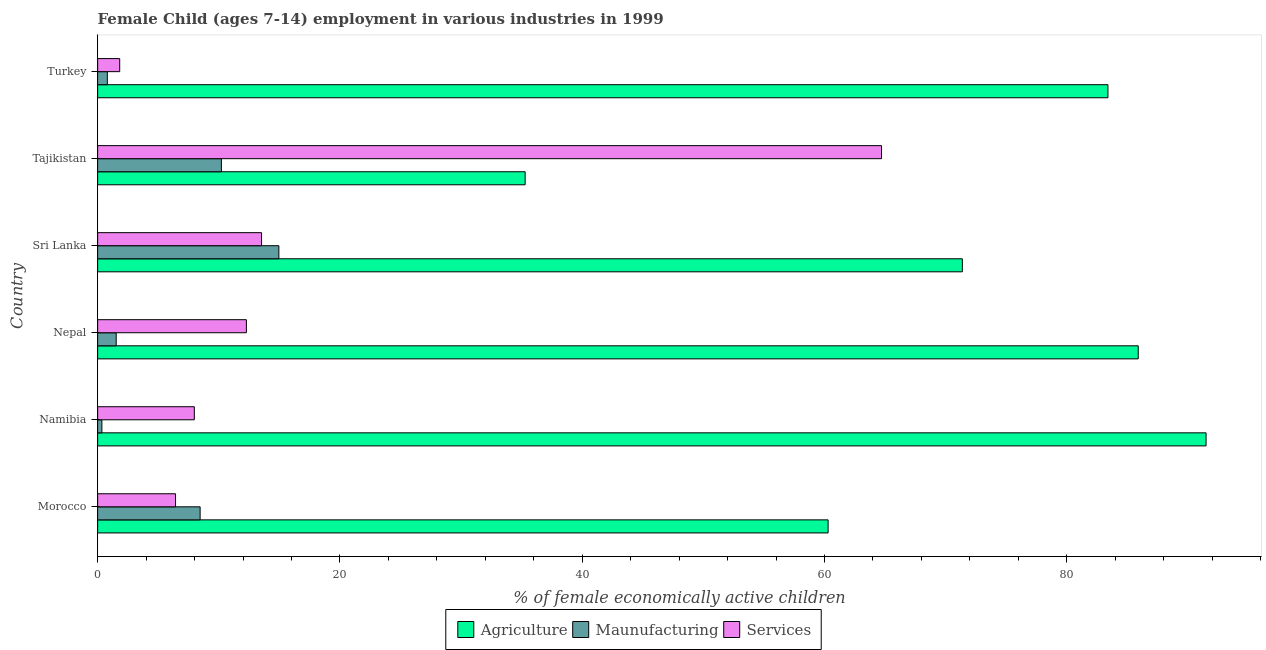How many groups of bars are there?
Your answer should be very brief. 6. What is the label of the 3rd group of bars from the top?
Your answer should be compact. Sri Lanka. In how many cases, is the number of bars for a given country not equal to the number of legend labels?
Provide a succinct answer. 0. What is the percentage of economically active children in agriculture in Nepal?
Offer a terse response. 85.9. Across all countries, what is the maximum percentage of economically active children in agriculture?
Offer a terse response. 91.5. In which country was the percentage of economically active children in agriculture maximum?
Ensure brevity in your answer.  Namibia. In which country was the percentage of economically active children in services minimum?
Keep it short and to the point. Turkey. What is the total percentage of economically active children in agriculture in the graph?
Your answer should be very brief. 427.77. What is the difference between the percentage of economically active children in agriculture in Sri Lanka and that in Turkey?
Provide a short and direct response. -12.02. What is the difference between the percentage of economically active children in agriculture in Morocco and the percentage of economically active children in services in Tajikistan?
Your answer should be very brief. -4.41. What is the average percentage of economically active children in services per country?
Your response must be concise. 17.79. What is the difference between the percentage of economically active children in services and percentage of economically active children in agriculture in Turkey?
Provide a short and direct response. -81.58. In how many countries, is the percentage of economically active children in agriculture greater than 12 %?
Make the answer very short. 6. What is the ratio of the percentage of economically active children in agriculture in Namibia to that in Turkey?
Keep it short and to the point. 1.1. Is the percentage of economically active children in services in Sri Lanka less than that in Turkey?
Provide a succinct answer. No. Is the difference between the percentage of economically active children in manufacturing in Morocco and Sri Lanka greater than the difference between the percentage of economically active children in services in Morocco and Sri Lanka?
Give a very brief answer. Yes. What is the difference between the highest and the second highest percentage of economically active children in manufacturing?
Your answer should be compact. 4.74. What is the difference between the highest and the lowest percentage of economically active children in agriculture?
Provide a short and direct response. 56.21. In how many countries, is the percentage of economically active children in agriculture greater than the average percentage of economically active children in agriculture taken over all countries?
Your response must be concise. 4. What does the 1st bar from the top in Nepal represents?
Ensure brevity in your answer.  Services. What does the 2nd bar from the bottom in Sri Lanka represents?
Keep it short and to the point. Maunufacturing. Are all the bars in the graph horizontal?
Your answer should be compact. Yes. How many countries are there in the graph?
Your answer should be compact. 6. Does the graph contain any zero values?
Ensure brevity in your answer.  No. How many legend labels are there?
Offer a terse response. 3. What is the title of the graph?
Provide a succinct answer. Female Child (ages 7-14) employment in various industries in 1999. Does "New Zealand" appear as one of the legend labels in the graph?
Offer a terse response. No. What is the label or title of the X-axis?
Give a very brief answer. % of female economically active children. What is the % of female economically active children of Agriculture in Morocco?
Ensure brevity in your answer.  60.3. What is the % of female economically active children in Maunufacturing in Morocco?
Your response must be concise. 8.46. What is the % of female economically active children in Services in Morocco?
Your response must be concise. 6.43. What is the % of female economically active children of Agriculture in Namibia?
Offer a terse response. 91.5. What is the % of female economically active children of Maunufacturing in Namibia?
Provide a short and direct response. 0.35. What is the % of female economically active children of Services in Namibia?
Ensure brevity in your answer.  7.98. What is the % of female economically active children of Agriculture in Nepal?
Your answer should be very brief. 85.9. What is the % of female economically active children in Maunufacturing in Nepal?
Ensure brevity in your answer.  1.53. What is the % of female economically active children in Services in Nepal?
Ensure brevity in your answer.  12.28. What is the % of female economically active children in Agriculture in Sri Lanka?
Provide a succinct answer. 71.38. What is the % of female economically active children of Maunufacturing in Sri Lanka?
Provide a short and direct response. 14.96. What is the % of female economically active children in Services in Sri Lanka?
Your answer should be very brief. 13.53. What is the % of female economically active children in Agriculture in Tajikistan?
Your response must be concise. 35.29. What is the % of female economically active children of Maunufacturing in Tajikistan?
Offer a very short reply. 10.22. What is the % of female economically active children of Services in Tajikistan?
Offer a terse response. 64.71. What is the % of female economically active children in Agriculture in Turkey?
Offer a very short reply. 83.4. What is the % of female economically active children of Services in Turkey?
Your answer should be very brief. 1.82. Across all countries, what is the maximum % of female economically active children of Agriculture?
Provide a short and direct response. 91.5. Across all countries, what is the maximum % of female economically active children of Maunufacturing?
Make the answer very short. 14.96. Across all countries, what is the maximum % of female economically active children of Services?
Your answer should be very brief. 64.71. Across all countries, what is the minimum % of female economically active children in Agriculture?
Offer a very short reply. 35.29. Across all countries, what is the minimum % of female economically active children of Services?
Your answer should be compact. 1.82. What is the total % of female economically active children of Agriculture in the graph?
Ensure brevity in your answer.  427.77. What is the total % of female economically active children in Maunufacturing in the graph?
Provide a short and direct response. 36.32. What is the total % of female economically active children in Services in the graph?
Make the answer very short. 106.75. What is the difference between the % of female economically active children of Agriculture in Morocco and that in Namibia?
Provide a succinct answer. -31.2. What is the difference between the % of female economically active children in Maunufacturing in Morocco and that in Namibia?
Provide a succinct answer. 8.11. What is the difference between the % of female economically active children of Services in Morocco and that in Namibia?
Give a very brief answer. -1.55. What is the difference between the % of female economically active children in Agriculture in Morocco and that in Nepal?
Your answer should be compact. -25.6. What is the difference between the % of female economically active children of Maunufacturing in Morocco and that in Nepal?
Your answer should be very brief. 6.93. What is the difference between the % of female economically active children in Services in Morocco and that in Nepal?
Provide a succinct answer. -5.85. What is the difference between the % of female economically active children in Agriculture in Morocco and that in Sri Lanka?
Provide a succinct answer. -11.08. What is the difference between the % of female economically active children of Services in Morocco and that in Sri Lanka?
Offer a very short reply. -7.1. What is the difference between the % of female economically active children in Agriculture in Morocco and that in Tajikistan?
Provide a short and direct response. 25.01. What is the difference between the % of female economically active children in Maunufacturing in Morocco and that in Tajikistan?
Keep it short and to the point. -1.76. What is the difference between the % of female economically active children of Services in Morocco and that in Tajikistan?
Keep it short and to the point. -58.28. What is the difference between the % of female economically active children in Agriculture in Morocco and that in Turkey?
Your answer should be compact. -23.1. What is the difference between the % of female economically active children of Maunufacturing in Morocco and that in Turkey?
Ensure brevity in your answer.  7.66. What is the difference between the % of female economically active children of Services in Morocco and that in Turkey?
Keep it short and to the point. 4.61. What is the difference between the % of female economically active children of Agriculture in Namibia and that in Nepal?
Provide a short and direct response. 5.6. What is the difference between the % of female economically active children of Maunufacturing in Namibia and that in Nepal?
Provide a succinct answer. -1.18. What is the difference between the % of female economically active children in Agriculture in Namibia and that in Sri Lanka?
Give a very brief answer. 20.12. What is the difference between the % of female economically active children in Maunufacturing in Namibia and that in Sri Lanka?
Offer a very short reply. -14.61. What is the difference between the % of female economically active children of Services in Namibia and that in Sri Lanka?
Ensure brevity in your answer.  -5.55. What is the difference between the % of female economically active children in Agriculture in Namibia and that in Tajikistan?
Your response must be concise. 56.21. What is the difference between the % of female economically active children of Maunufacturing in Namibia and that in Tajikistan?
Make the answer very short. -9.87. What is the difference between the % of female economically active children of Services in Namibia and that in Tajikistan?
Ensure brevity in your answer.  -56.73. What is the difference between the % of female economically active children in Agriculture in Namibia and that in Turkey?
Give a very brief answer. 8.1. What is the difference between the % of female economically active children of Maunufacturing in Namibia and that in Turkey?
Make the answer very short. -0.45. What is the difference between the % of female economically active children in Services in Namibia and that in Turkey?
Your answer should be compact. 6.16. What is the difference between the % of female economically active children of Agriculture in Nepal and that in Sri Lanka?
Keep it short and to the point. 14.52. What is the difference between the % of female economically active children in Maunufacturing in Nepal and that in Sri Lanka?
Give a very brief answer. -13.43. What is the difference between the % of female economically active children of Services in Nepal and that in Sri Lanka?
Give a very brief answer. -1.25. What is the difference between the % of female economically active children in Agriculture in Nepal and that in Tajikistan?
Your answer should be very brief. 50.61. What is the difference between the % of female economically active children in Maunufacturing in Nepal and that in Tajikistan?
Your answer should be compact. -8.68. What is the difference between the % of female economically active children of Services in Nepal and that in Tajikistan?
Offer a terse response. -52.43. What is the difference between the % of female economically active children of Agriculture in Nepal and that in Turkey?
Make the answer very short. 2.5. What is the difference between the % of female economically active children in Maunufacturing in Nepal and that in Turkey?
Your answer should be very brief. 0.73. What is the difference between the % of female economically active children in Services in Nepal and that in Turkey?
Your answer should be compact. 10.46. What is the difference between the % of female economically active children of Agriculture in Sri Lanka and that in Tajikistan?
Your answer should be compact. 36.09. What is the difference between the % of female economically active children in Maunufacturing in Sri Lanka and that in Tajikistan?
Your answer should be compact. 4.74. What is the difference between the % of female economically active children of Services in Sri Lanka and that in Tajikistan?
Your answer should be very brief. -51.18. What is the difference between the % of female economically active children of Agriculture in Sri Lanka and that in Turkey?
Ensure brevity in your answer.  -12.02. What is the difference between the % of female economically active children of Maunufacturing in Sri Lanka and that in Turkey?
Your answer should be compact. 14.16. What is the difference between the % of female economically active children of Services in Sri Lanka and that in Turkey?
Ensure brevity in your answer.  11.71. What is the difference between the % of female economically active children in Agriculture in Tajikistan and that in Turkey?
Your answer should be very brief. -48.11. What is the difference between the % of female economically active children of Maunufacturing in Tajikistan and that in Turkey?
Your answer should be compact. 9.42. What is the difference between the % of female economically active children in Services in Tajikistan and that in Turkey?
Your answer should be very brief. 62.89. What is the difference between the % of female economically active children of Agriculture in Morocco and the % of female economically active children of Maunufacturing in Namibia?
Ensure brevity in your answer.  59.95. What is the difference between the % of female economically active children in Agriculture in Morocco and the % of female economically active children in Services in Namibia?
Offer a very short reply. 52.32. What is the difference between the % of female economically active children in Maunufacturing in Morocco and the % of female economically active children in Services in Namibia?
Provide a short and direct response. 0.48. What is the difference between the % of female economically active children in Agriculture in Morocco and the % of female economically active children in Maunufacturing in Nepal?
Your answer should be very brief. 58.77. What is the difference between the % of female economically active children of Agriculture in Morocco and the % of female economically active children of Services in Nepal?
Offer a terse response. 48.02. What is the difference between the % of female economically active children of Maunufacturing in Morocco and the % of female economically active children of Services in Nepal?
Your response must be concise. -3.82. What is the difference between the % of female economically active children in Agriculture in Morocco and the % of female economically active children in Maunufacturing in Sri Lanka?
Provide a succinct answer. 45.34. What is the difference between the % of female economically active children of Agriculture in Morocco and the % of female economically active children of Services in Sri Lanka?
Your response must be concise. 46.77. What is the difference between the % of female economically active children in Maunufacturing in Morocco and the % of female economically active children in Services in Sri Lanka?
Provide a short and direct response. -5.07. What is the difference between the % of female economically active children in Agriculture in Morocco and the % of female economically active children in Maunufacturing in Tajikistan?
Keep it short and to the point. 50.08. What is the difference between the % of female economically active children in Agriculture in Morocco and the % of female economically active children in Services in Tajikistan?
Your response must be concise. -4.41. What is the difference between the % of female economically active children of Maunufacturing in Morocco and the % of female economically active children of Services in Tajikistan?
Provide a succinct answer. -56.25. What is the difference between the % of female economically active children of Agriculture in Morocco and the % of female economically active children of Maunufacturing in Turkey?
Provide a succinct answer. 59.5. What is the difference between the % of female economically active children in Agriculture in Morocco and the % of female economically active children in Services in Turkey?
Your answer should be compact. 58.48. What is the difference between the % of female economically active children of Maunufacturing in Morocco and the % of female economically active children of Services in Turkey?
Provide a short and direct response. 6.64. What is the difference between the % of female economically active children of Agriculture in Namibia and the % of female economically active children of Maunufacturing in Nepal?
Make the answer very short. 89.97. What is the difference between the % of female economically active children of Agriculture in Namibia and the % of female economically active children of Services in Nepal?
Provide a succinct answer. 79.22. What is the difference between the % of female economically active children in Maunufacturing in Namibia and the % of female economically active children in Services in Nepal?
Your answer should be compact. -11.93. What is the difference between the % of female economically active children of Agriculture in Namibia and the % of female economically active children of Maunufacturing in Sri Lanka?
Provide a succinct answer. 76.54. What is the difference between the % of female economically active children in Agriculture in Namibia and the % of female economically active children in Services in Sri Lanka?
Your answer should be very brief. 77.97. What is the difference between the % of female economically active children of Maunufacturing in Namibia and the % of female economically active children of Services in Sri Lanka?
Your answer should be compact. -13.18. What is the difference between the % of female economically active children of Agriculture in Namibia and the % of female economically active children of Maunufacturing in Tajikistan?
Your response must be concise. 81.28. What is the difference between the % of female economically active children in Agriculture in Namibia and the % of female economically active children in Services in Tajikistan?
Make the answer very short. 26.79. What is the difference between the % of female economically active children in Maunufacturing in Namibia and the % of female economically active children in Services in Tajikistan?
Provide a succinct answer. -64.36. What is the difference between the % of female economically active children of Agriculture in Namibia and the % of female economically active children of Maunufacturing in Turkey?
Offer a very short reply. 90.7. What is the difference between the % of female economically active children of Agriculture in Namibia and the % of female economically active children of Services in Turkey?
Provide a succinct answer. 89.68. What is the difference between the % of female economically active children of Maunufacturing in Namibia and the % of female economically active children of Services in Turkey?
Offer a terse response. -1.47. What is the difference between the % of female economically active children in Agriculture in Nepal and the % of female economically active children in Maunufacturing in Sri Lanka?
Give a very brief answer. 70.94. What is the difference between the % of female economically active children of Agriculture in Nepal and the % of female economically active children of Services in Sri Lanka?
Your answer should be very brief. 72.37. What is the difference between the % of female economically active children of Maunufacturing in Nepal and the % of female economically active children of Services in Sri Lanka?
Make the answer very short. -12. What is the difference between the % of female economically active children in Agriculture in Nepal and the % of female economically active children in Maunufacturing in Tajikistan?
Keep it short and to the point. 75.68. What is the difference between the % of female economically active children in Agriculture in Nepal and the % of female economically active children in Services in Tajikistan?
Keep it short and to the point. 21.19. What is the difference between the % of female economically active children in Maunufacturing in Nepal and the % of female economically active children in Services in Tajikistan?
Keep it short and to the point. -63.18. What is the difference between the % of female economically active children in Agriculture in Nepal and the % of female economically active children in Maunufacturing in Turkey?
Your response must be concise. 85.1. What is the difference between the % of female economically active children in Agriculture in Nepal and the % of female economically active children in Services in Turkey?
Provide a succinct answer. 84.08. What is the difference between the % of female economically active children in Maunufacturing in Nepal and the % of female economically active children in Services in Turkey?
Make the answer very short. -0.29. What is the difference between the % of female economically active children of Agriculture in Sri Lanka and the % of female economically active children of Maunufacturing in Tajikistan?
Your answer should be compact. 61.16. What is the difference between the % of female economically active children of Agriculture in Sri Lanka and the % of female economically active children of Services in Tajikistan?
Your answer should be compact. 6.67. What is the difference between the % of female economically active children of Maunufacturing in Sri Lanka and the % of female economically active children of Services in Tajikistan?
Your answer should be compact. -49.75. What is the difference between the % of female economically active children of Agriculture in Sri Lanka and the % of female economically active children of Maunufacturing in Turkey?
Offer a very short reply. 70.58. What is the difference between the % of female economically active children of Agriculture in Sri Lanka and the % of female economically active children of Services in Turkey?
Offer a very short reply. 69.56. What is the difference between the % of female economically active children in Maunufacturing in Sri Lanka and the % of female economically active children in Services in Turkey?
Give a very brief answer. 13.14. What is the difference between the % of female economically active children in Agriculture in Tajikistan and the % of female economically active children in Maunufacturing in Turkey?
Give a very brief answer. 34.49. What is the difference between the % of female economically active children of Agriculture in Tajikistan and the % of female economically active children of Services in Turkey?
Offer a terse response. 33.47. What is the difference between the % of female economically active children of Maunufacturing in Tajikistan and the % of female economically active children of Services in Turkey?
Give a very brief answer. 8.39. What is the average % of female economically active children in Agriculture per country?
Keep it short and to the point. 71.3. What is the average % of female economically active children in Maunufacturing per country?
Your response must be concise. 6.05. What is the average % of female economically active children of Services per country?
Your answer should be compact. 17.79. What is the difference between the % of female economically active children in Agriculture and % of female economically active children in Maunufacturing in Morocco?
Offer a terse response. 51.84. What is the difference between the % of female economically active children in Agriculture and % of female economically active children in Services in Morocco?
Keep it short and to the point. 53.87. What is the difference between the % of female economically active children of Maunufacturing and % of female economically active children of Services in Morocco?
Your answer should be very brief. 2.03. What is the difference between the % of female economically active children in Agriculture and % of female economically active children in Maunufacturing in Namibia?
Give a very brief answer. 91.15. What is the difference between the % of female economically active children in Agriculture and % of female economically active children in Services in Namibia?
Provide a succinct answer. 83.52. What is the difference between the % of female economically active children of Maunufacturing and % of female economically active children of Services in Namibia?
Give a very brief answer. -7.63. What is the difference between the % of female economically active children in Agriculture and % of female economically active children in Maunufacturing in Nepal?
Keep it short and to the point. 84.37. What is the difference between the % of female economically active children of Agriculture and % of female economically active children of Services in Nepal?
Your response must be concise. 73.62. What is the difference between the % of female economically active children of Maunufacturing and % of female economically active children of Services in Nepal?
Provide a succinct answer. -10.75. What is the difference between the % of female economically active children in Agriculture and % of female economically active children in Maunufacturing in Sri Lanka?
Keep it short and to the point. 56.42. What is the difference between the % of female economically active children of Agriculture and % of female economically active children of Services in Sri Lanka?
Make the answer very short. 57.85. What is the difference between the % of female economically active children in Maunufacturing and % of female economically active children in Services in Sri Lanka?
Your answer should be compact. 1.43. What is the difference between the % of female economically active children of Agriculture and % of female economically active children of Maunufacturing in Tajikistan?
Your response must be concise. 25.07. What is the difference between the % of female economically active children in Agriculture and % of female economically active children in Services in Tajikistan?
Give a very brief answer. -29.42. What is the difference between the % of female economically active children of Maunufacturing and % of female economically active children of Services in Tajikistan?
Ensure brevity in your answer.  -54.49. What is the difference between the % of female economically active children of Agriculture and % of female economically active children of Maunufacturing in Turkey?
Offer a very short reply. 82.6. What is the difference between the % of female economically active children in Agriculture and % of female economically active children in Services in Turkey?
Keep it short and to the point. 81.58. What is the difference between the % of female economically active children in Maunufacturing and % of female economically active children in Services in Turkey?
Your answer should be compact. -1.02. What is the ratio of the % of female economically active children in Agriculture in Morocco to that in Namibia?
Give a very brief answer. 0.66. What is the ratio of the % of female economically active children of Maunufacturing in Morocco to that in Namibia?
Ensure brevity in your answer.  24.17. What is the ratio of the % of female economically active children in Services in Morocco to that in Namibia?
Provide a short and direct response. 0.81. What is the ratio of the % of female economically active children of Agriculture in Morocco to that in Nepal?
Provide a short and direct response. 0.7. What is the ratio of the % of female economically active children in Maunufacturing in Morocco to that in Nepal?
Your answer should be compact. 5.52. What is the ratio of the % of female economically active children in Services in Morocco to that in Nepal?
Make the answer very short. 0.52. What is the ratio of the % of female economically active children in Agriculture in Morocco to that in Sri Lanka?
Provide a short and direct response. 0.84. What is the ratio of the % of female economically active children in Maunufacturing in Morocco to that in Sri Lanka?
Provide a succinct answer. 0.57. What is the ratio of the % of female economically active children in Services in Morocco to that in Sri Lanka?
Keep it short and to the point. 0.48. What is the ratio of the % of female economically active children in Agriculture in Morocco to that in Tajikistan?
Ensure brevity in your answer.  1.71. What is the ratio of the % of female economically active children of Maunufacturing in Morocco to that in Tajikistan?
Give a very brief answer. 0.83. What is the ratio of the % of female economically active children of Services in Morocco to that in Tajikistan?
Your answer should be compact. 0.1. What is the ratio of the % of female economically active children of Agriculture in Morocco to that in Turkey?
Give a very brief answer. 0.72. What is the ratio of the % of female economically active children in Maunufacturing in Morocco to that in Turkey?
Provide a short and direct response. 10.57. What is the ratio of the % of female economically active children in Services in Morocco to that in Turkey?
Offer a very short reply. 3.53. What is the ratio of the % of female economically active children of Agriculture in Namibia to that in Nepal?
Your answer should be compact. 1.07. What is the ratio of the % of female economically active children in Maunufacturing in Namibia to that in Nepal?
Make the answer very short. 0.23. What is the ratio of the % of female economically active children of Services in Namibia to that in Nepal?
Give a very brief answer. 0.65. What is the ratio of the % of female economically active children of Agriculture in Namibia to that in Sri Lanka?
Your response must be concise. 1.28. What is the ratio of the % of female economically active children of Maunufacturing in Namibia to that in Sri Lanka?
Give a very brief answer. 0.02. What is the ratio of the % of female economically active children in Services in Namibia to that in Sri Lanka?
Offer a terse response. 0.59. What is the ratio of the % of female economically active children in Agriculture in Namibia to that in Tajikistan?
Offer a terse response. 2.59. What is the ratio of the % of female economically active children in Maunufacturing in Namibia to that in Tajikistan?
Offer a terse response. 0.03. What is the ratio of the % of female economically active children of Services in Namibia to that in Tajikistan?
Make the answer very short. 0.12. What is the ratio of the % of female economically active children of Agriculture in Namibia to that in Turkey?
Keep it short and to the point. 1.1. What is the ratio of the % of female economically active children in Maunufacturing in Namibia to that in Turkey?
Your answer should be compact. 0.44. What is the ratio of the % of female economically active children in Services in Namibia to that in Turkey?
Provide a short and direct response. 4.38. What is the ratio of the % of female economically active children of Agriculture in Nepal to that in Sri Lanka?
Your answer should be very brief. 1.2. What is the ratio of the % of female economically active children of Maunufacturing in Nepal to that in Sri Lanka?
Provide a succinct answer. 0.1. What is the ratio of the % of female economically active children of Services in Nepal to that in Sri Lanka?
Make the answer very short. 0.91. What is the ratio of the % of female economically active children in Agriculture in Nepal to that in Tajikistan?
Keep it short and to the point. 2.43. What is the ratio of the % of female economically active children in Maunufacturing in Nepal to that in Tajikistan?
Keep it short and to the point. 0.15. What is the ratio of the % of female economically active children in Services in Nepal to that in Tajikistan?
Your answer should be compact. 0.19. What is the ratio of the % of female economically active children in Agriculture in Nepal to that in Turkey?
Make the answer very short. 1.03. What is the ratio of the % of female economically active children in Maunufacturing in Nepal to that in Turkey?
Provide a short and direct response. 1.91. What is the ratio of the % of female economically active children of Services in Nepal to that in Turkey?
Keep it short and to the point. 6.74. What is the ratio of the % of female economically active children of Agriculture in Sri Lanka to that in Tajikistan?
Offer a terse response. 2.02. What is the ratio of the % of female economically active children of Maunufacturing in Sri Lanka to that in Tajikistan?
Offer a very short reply. 1.46. What is the ratio of the % of female economically active children of Services in Sri Lanka to that in Tajikistan?
Provide a succinct answer. 0.21. What is the ratio of the % of female economically active children of Agriculture in Sri Lanka to that in Turkey?
Provide a succinct answer. 0.86. What is the ratio of the % of female economically active children in Maunufacturing in Sri Lanka to that in Turkey?
Make the answer very short. 18.7. What is the ratio of the % of female economically active children in Services in Sri Lanka to that in Turkey?
Provide a short and direct response. 7.43. What is the ratio of the % of female economically active children in Agriculture in Tajikistan to that in Turkey?
Ensure brevity in your answer.  0.42. What is the ratio of the % of female economically active children in Maunufacturing in Tajikistan to that in Turkey?
Keep it short and to the point. 12.77. What is the ratio of the % of female economically active children in Services in Tajikistan to that in Turkey?
Your response must be concise. 35.53. What is the difference between the highest and the second highest % of female economically active children of Agriculture?
Your answer should be very brief. 5.6. What is the difference between the highest and the second highest % of female economically active children of Maunufacturing?
Keep it short and to the point. 4.74. What is the difference between the highest and the second highest % of female economically active children of Services?
Make the answer very short. 51.18. What is the difference between the highest and the lowest % of female economically active children of Agriculture?
Offer a very short reply. 56.21. What is the difference between the highest and the lowest % of female economically active children in Maunufacturing?
Your response must be concise. 14.61. What is the difference between the highest and the lowest % of female economically active children in Services?
Give a very brief answer. 62.89. 